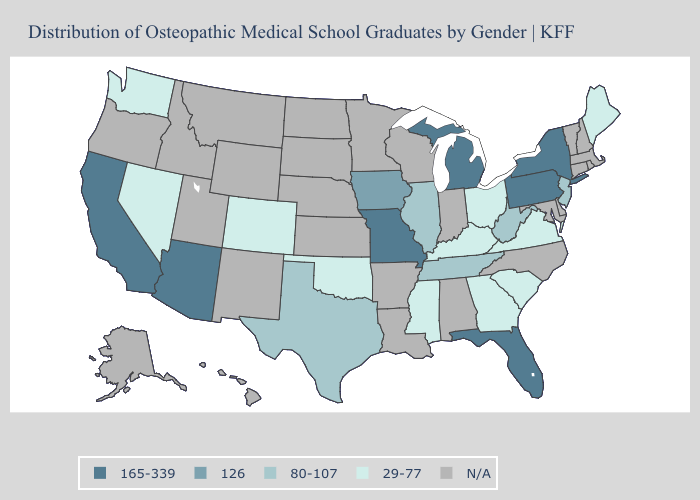Name the states that have a value in the range 126?
Be succinct. Iowa. Name the states that have a value in the range N/A?
Keep it brief. Alabama, Alaska, Arkansas, Connecticut, Delaware, Hawaii, Idaho, Indiana, Kansas, Louisiana, Maryland, Massachusetts, Minnesota, Montana, Nebraska, New Hampshire, New Mexico, North Carolina, North Dakota, Oregon, Rhode Island, South Dakota, Utah, Vermont, Wisconsin, Wyoming. Does the first symbol in the legend represent the smallest category?
Answer briefly. No. What is the value of Nevada?
Be succinct. 29-77. Does the first symbol in the legend represent the smallest category?
Short answer required. No. What is the value of Pennsylvania?
Be succinct. 165-339. Does Michigan have the lowest value in the USA?
Be succinct. No. What is the value of Alabama?
Be succinct. N/A. What is the value of Minnesota?
Answer briefly. N/A. What is the highest value in the Northeast ?
Write a very short answer. 165-339. Name the states that have a value in the range N/A?
Give a very brief answer. Alabama, Alaska, Arkansas, Connecticut, Delaware, Hawaii, Idaho, Indiana, Kansas, Louisiana, Maryland, Massachusetts, Minnesota, Montana, Nebraska, New Hampshire, New Mexico, North Carolina, North Dakota, Oregon, Rhode Island, South Dakota, Utah, Vermont, Wisconsin, Wyoming. Is the legend a continuous bar?
Quick response, please. No. What is the value of Texas?
Short answer required. 80-107. 